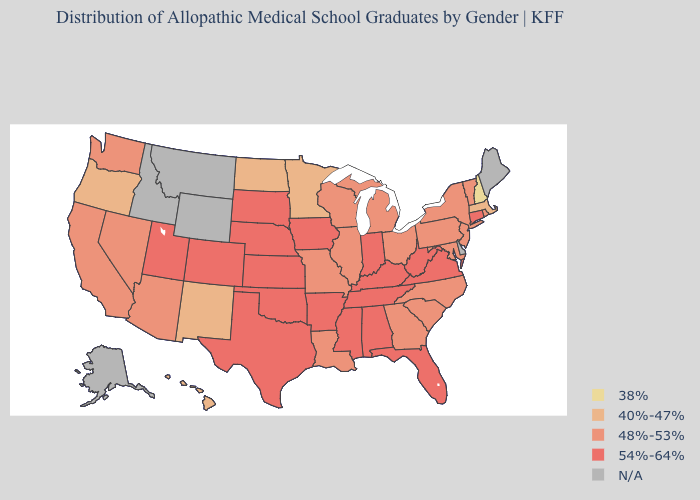What is the highest value in states that border West Virginia?
Concise answer only. 54%-64%. What is the lowest value in states that border Kansas?
Concise answer only. 48%-53%. Is the legend a continuous bar?
Short answer required. No. Name the states that have a value in the range 48%-53%?
Answer briefly. Arizona, California, Georgia, Illinois, Louisiana, Maryland, Michigan, Missouri, Nevada, New Jersey, New York, North Carolina, Ohio, Pennsylvania, Rhode Island, South Carolina, Vermont, Washington, Wisconsin. What is the highest value in states that border Pennsylvania?
Keep it brief. 54%-64%. Does the map have missing data?
Short answer required. Yes. What is the value of Rhode Island?
Quick response, please. 48%-53%. Among the states that border Maine , which have the lowest value?
Keep it brief. New Hampshire. What is the value of Maine?
Short answer required. N/A. What is the highest value in states that border Kansas?
Write a very short answer. 54%-64%. Does Oregon have the lowest value in the West?
Keep it brief. Yes. Among the states that border Utah , which have the lowest value?
Concise answer only. New Mexico. 